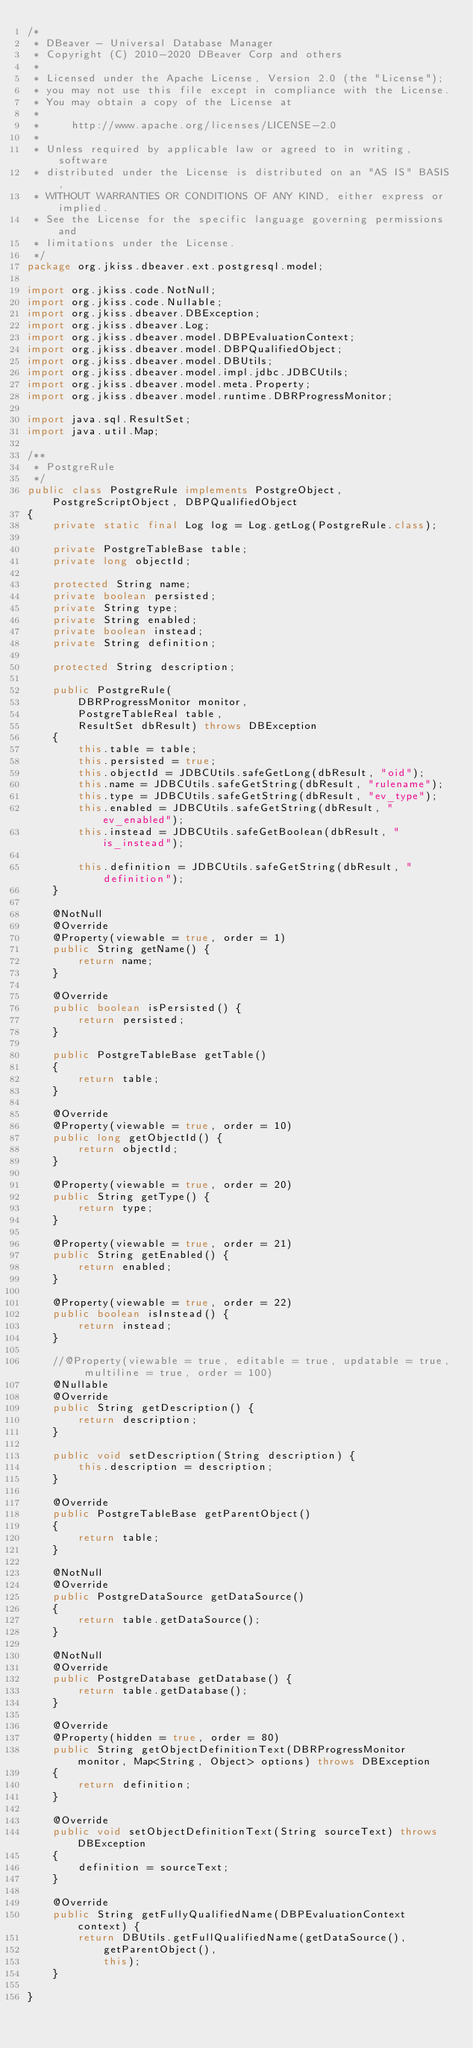Convert code to text. <code><loc_0><loc_0><loc_500><loc_500><_Java_>/*
 * DBeaver - Universal Database Manager
 * Copyright (C) 2010-2020 DBeaver Corp and others
 *
 * Licensed under the Apache License, Version 2.0 (the "License");
 * you may not use this file except in compliance with the License.
 * You may obtain a copy of the License at
 *
 *     http://www.apache.org/licenses/LICENSE-2.0
 *
 * Unless required by applicable law or agreed to in writing, software
 * distributed under the License is distributed on an "AS IS" BASIS,
 * WITHOUT WARRANTIES OR CONDITIONS OF ANY KIND, either express or implied.
 * See the License for the specific language governing permissions and
 * limitations under the License.
 */
package org.jkiss.dbeaver.ext.postgresql.model;

import org.jkiss.code.NotNull;
import org.jkiss.code.Nullable;
import org.jkiss.dbeaver.DBException;
import org.jkiss.dbeaver.Log;
import org.jkiss.dbeaver.model.DBPEvaluationContext;
import org.jkiss.dbeaver.model.DBPQualifiedObject;
import org.jkiss.dbeaver.model.DBUtils;
import org.jkiss.dbeaver.model.impl.jdbc.JDBCUtils;
import org.jkiss.dbeaver.model.meta.Property;
import org.jkiss.dbeaver.model.runtime.DBRProgressMonitor;

import java.sql.ResultSet;
import java.util.Map;

/**
 * PostgreRule
 */
public class PostgreRule implements PostgreObject, PostgreScriptObject, DBPQualifiedObject
{
    private static final Log log = Log.getLog(PostgreRule.class);

    private PostgreTableBase table;
    private long objectId;

    protected String name;
    private boolean persisted;
    private String type;
    private String enabled;
    private boolean instead;
    private String definition;

    protected String description;

    public PostgreRule(
        DBRProgressMonitor monitor,
        PostgreTableReal table,
        ResultSet dbResult) throws DBException
    {
        this.table = table;
        this.persisted = true;
        this.objectId = JDBCUtils.safeGetLong(dbResult, "oid");
        this.name = JDBCUtils.safeGetString(dbResult, "rulename");
        this.type = JDBCUtils.safeGetString(dbResult, "ev_type");
        this.enabled = JDBCUtils.safeGetString(dbResult, "ev_enabled");
        this.instead = JDBCUtils.safeGetBoolean(dbResult, "is_instead");

        this.definition = JDBCUtils.safeGetString(dbResult, "definition");
    }

    @NotNull
    @Override
    @Property(viewable = true, order = 1)
    public String getName() {
        return name;
    }

    @Override
    public boolean isPersisted() {
        return persisted;
    }

    public PostgreTableBase getTable()
    {
        return table;
    }

    @Override
    @Property(viewable = true, order = 10)
    public long getObjectId() {
        return objectId;
    }

    @Property(viewable = true, order = 20)
    public String getType() {
        return type;
    }

    @Property(viewable = true, order = 21)
    public String getEnabled() {
        return enabled;
    }

    @Property(viewable = true, order = 22)
    public boolean isInstead() {
        return instead;
    }

    //@Property(viewable = true, editable = true, updatable = true, multiline = true, order = 100)
    @Nullable
    @Override
    public String getDescription() {
        return description;
    }

    public void setDescription(String description) {
        this.description = description;
    }

    @Override
    public PostgreTableBase getParentObject()
    {
        return table;
    }

    @NotNull
    @Override
    public PostgreDataSource getDataSource()
    {
        return table.getDataSource();
    }

    @NotNull
    @Override
    public PostgreDatabase getDatabase() {
        return table.getDatabase();
    }

    @Override
    @Property(hidden = true, order = 80)
    public String getObjectDefinitionText(DBRProgressMonitor monitor, Map<String, Object> options) throws DBException
    {
        return definition;
    }

    @Override
    public void setObjectDefinitionText(String sourceText) throws DBException
    {
        definition = sourceText;
    }

    @Override
    public String getFullyQualifiedName(DBPEvaluationContext context) {
        return DBUtils.getFullQualifiedName(getDataSource(),
            getParentObject(),
            this);
    }

}
</code> 